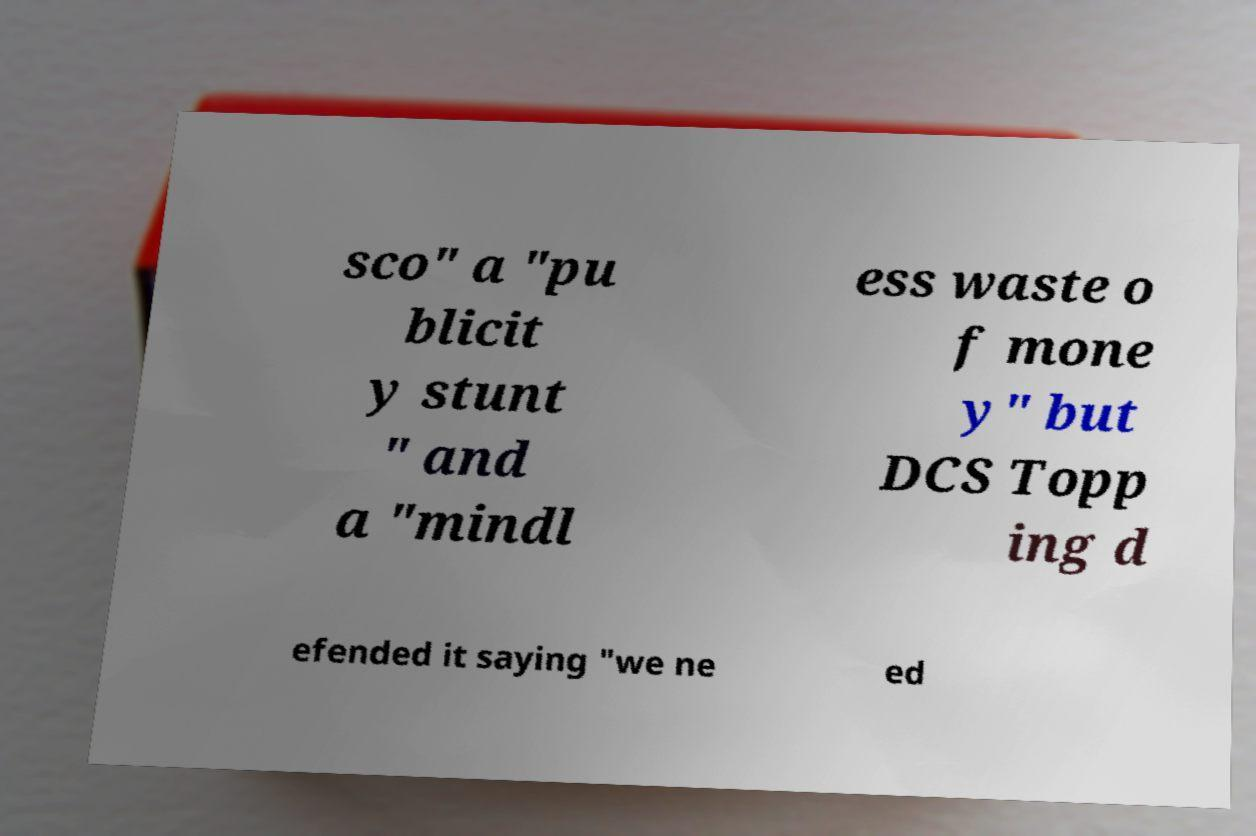I need the written content from this picture converted into text. Can you do that? sco" a "pu blicit y stunt " and a "mindl ess waste o f mone y" but DCS Topp ing d efended it saying "we ne ed 